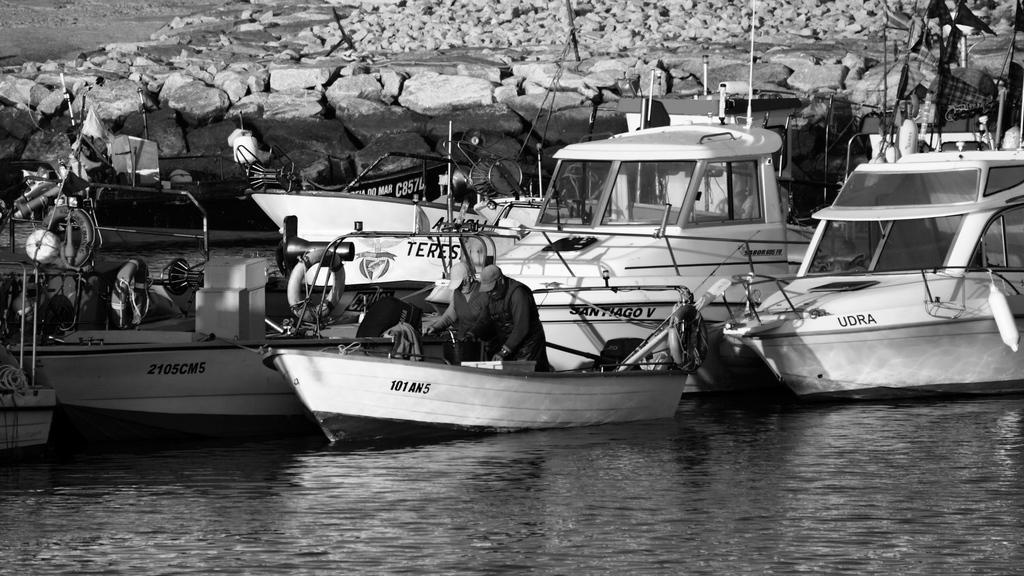<image>
Summarize the visual content of the image. A black and white photo of several boats, the closest one is marked 101AN5. 